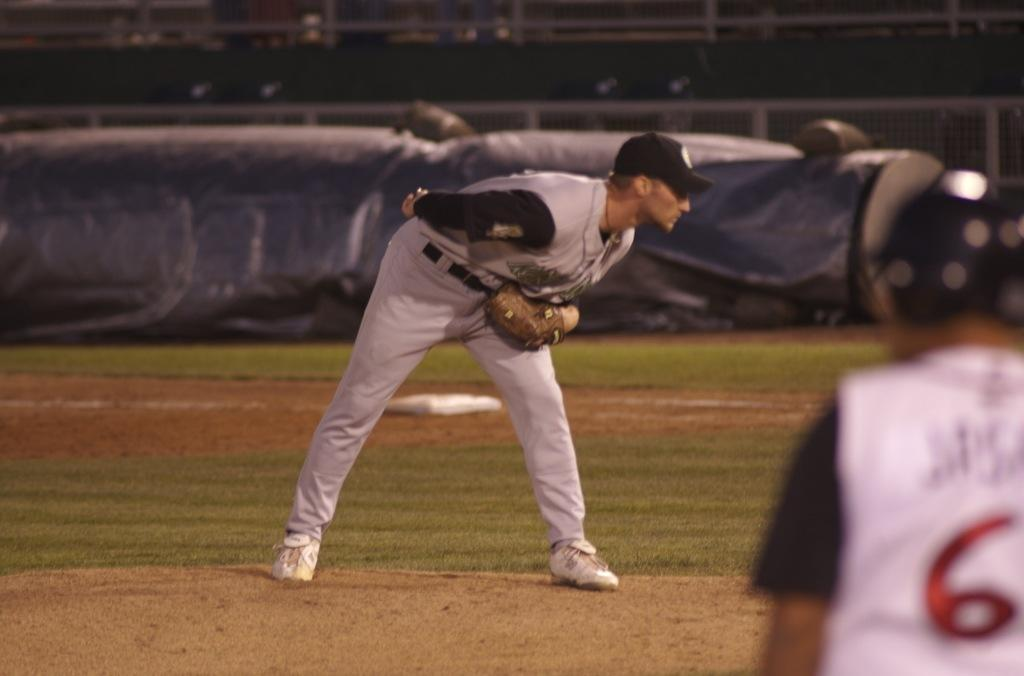Provide a one-sentence caption for the provided image. Player 6 anxiously awaited a chance to steal home. 